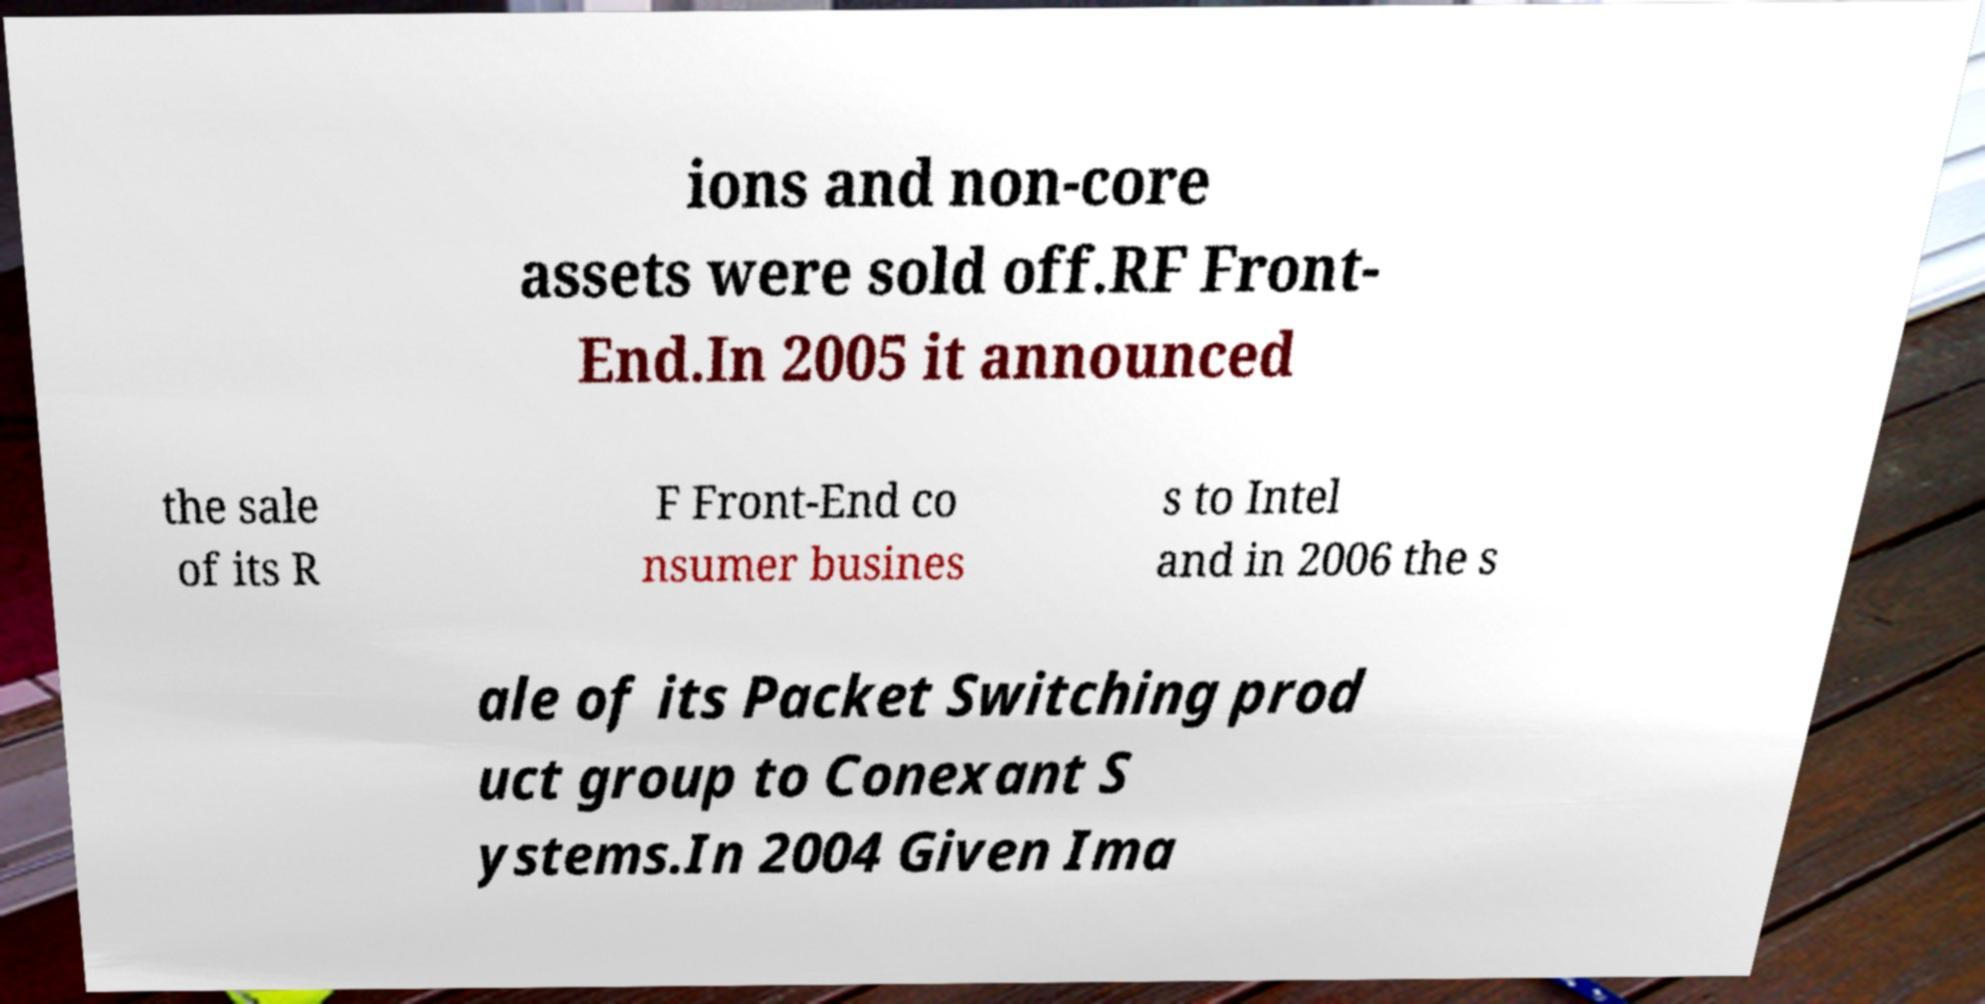Can you read and provide the text displayed in the image?This photo seems to have some interesting text. Can you extract and type it out for me? ions and non-core assets were sold off.RF Front- End.In 2005 it announced the sale of its R F Front-End co nsumer busines s to Intel and in 2006 the s ale of its Packet Switching prod uct group to Conexant S ystems.In 2004 Given Ima 